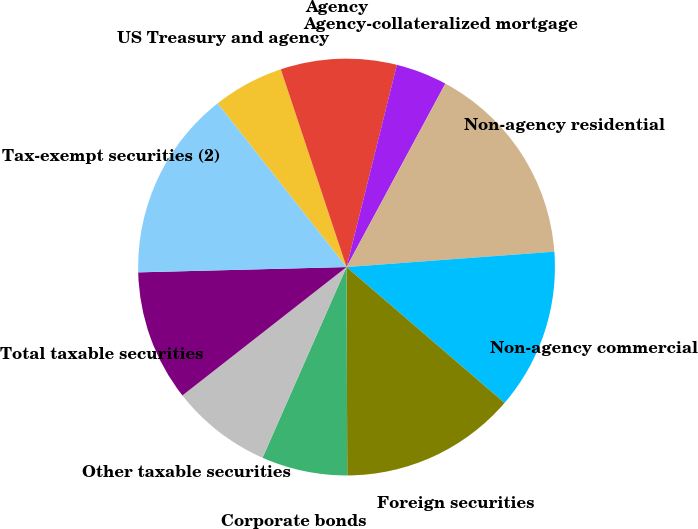Convert chart to OTSL. <chart><loc_0><loc_0><loc_500><loc_500><pie_chart><fcel>US Treasury and agency<fcel>Agency<fcel>Agency-collateralized mortgage<fcel>Non-agency residential<fcel>Non-agency commercial<fcel>Foreign securities<fcel>Corporate bonds<fcel>Other taxable securities<fcel>Total taxable securities<fcel>Tax-exempt securities (2)<nl><fcel>5.51%<fcel>8.99%<fcel>3.98%<fcel>15.96%<fcel>12.48%<fcel>13.64%<fcel>6.66%<fcel>7.83%<fcel>10.16%<fcel>14.79%<nl></chart> 